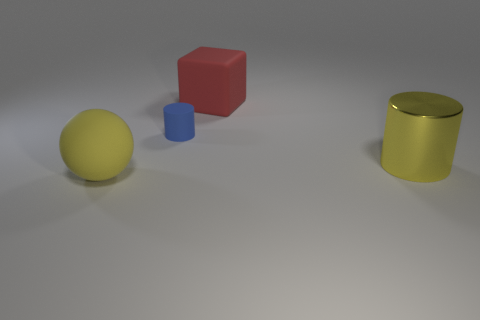Add 4 red rubber things. How many objects exist? 8 Subtract all blocks. How many objects are left? 3 Subtract all purple cylinders. Subtract all matte cubes. How many objects are left? 3 Add 3 blue matte cylinders. How many blue matte cylinders are left? 4 Add 3 big balls. How many big balls exist? 4 Subtract 0 brown blocks. How many objects are left? 4 